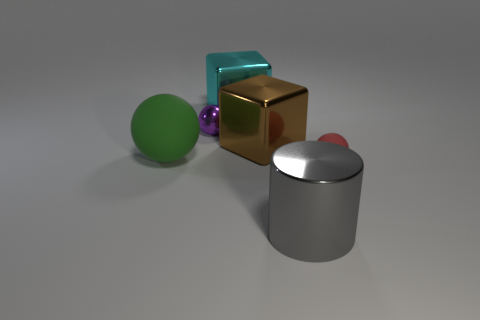What size is the red object that is the same shape as the green thing?
Make the answer very short. Small. Is the number of cyan blocks on the left side of the green matte ball greater than the number of rubber things right of the purple ball?
Provide a short and direct response. No. Are the green sphere and the small thing in front of the large green rubber ball made of the same material?
Offer a very short reply. Yes. Are there any other things that have the same shape as the small red rubber thing?
Give a very brief answer. Yes. What is the color of the sphere that is both in front of the big brown block and to the left of the small rubber thing?
Your answer should be compact. Green. The gray metal thing that is in front of the tiny metallic ball has what shape?
Offer a very short reply. Cylinder. There is a matte sphere in front of the large thing on the left side of the tiny thing that is behind the red matte ball; how big is it?
Ensure brevity in your answer.  Small. There is a small sphere that is on the right side of the big gray cylinder; how many tiny red rubber spheres are behind it?
Your response must be concise. 0. How big is the object that is both in front of the large green object and left of the tiny red object?
Make the answer very short. Large. How many shiny things are tiny brown spheres or gray objects?
Provide a succinct answer. 1. 